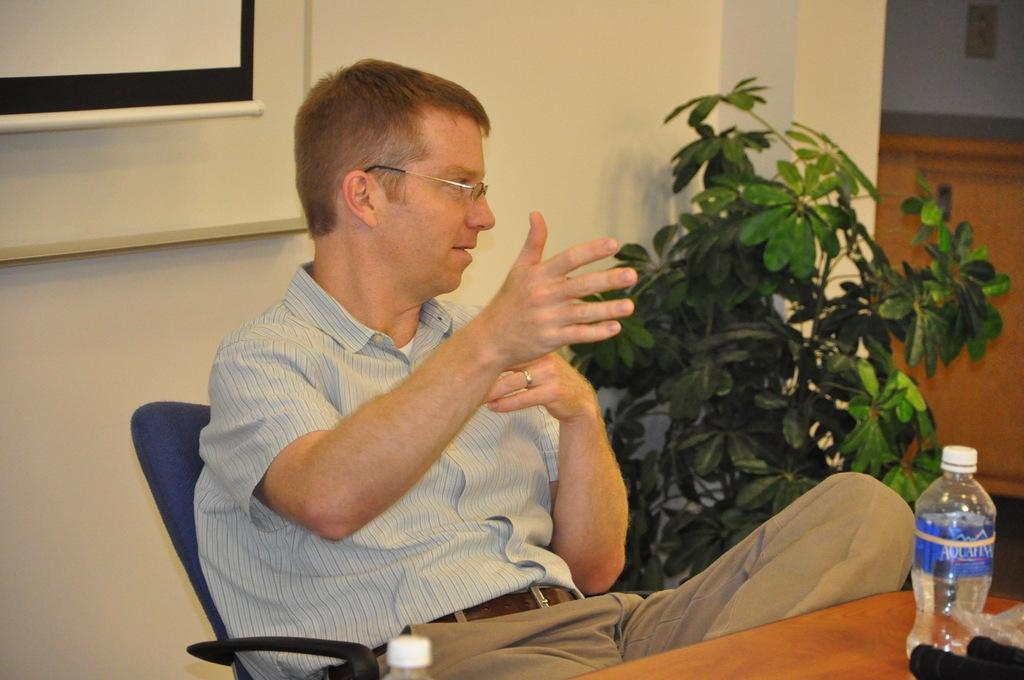What is the man in the image doing? The man is sitting on a seat in the image. What is in front of the man? There is a table in front of the man. What objects are on the table? There are two bottles on the table. What can be seen in the background of the image? There is a wall and a plant in the background of the image. What type of flower is the chicken holding in the image? There is no flower or chicken present in the image. 